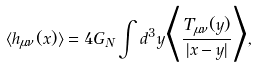<formula> <loc_0><loc_0><loc_500><loc_500>\langle h _ { \mu \nu } ( x ) \rangle = 4 G _ { N } \int d ^ { 3 } y \Big { \langle } \frac { T _ { \mu \nu } ( y ) } { | x - y | } \Big { \rangle } ,</formula> 